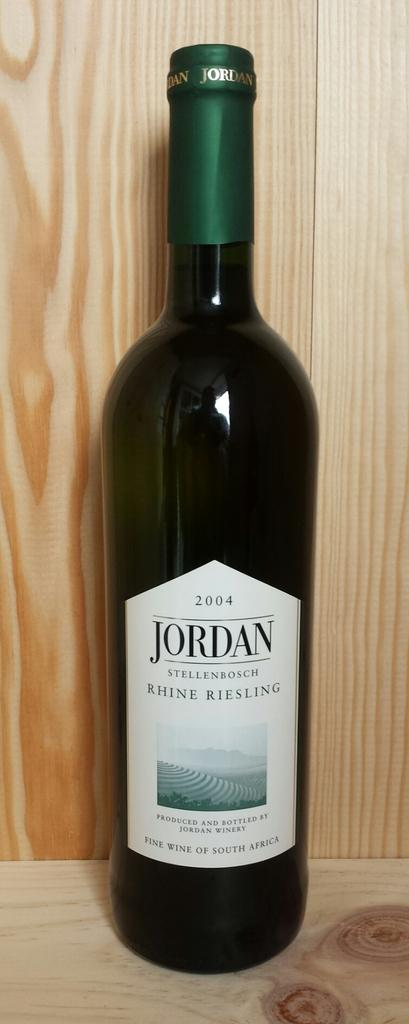<image>
Create a compact narrative representing the image presented. A bottle of 2004 riesling from South Africa. 